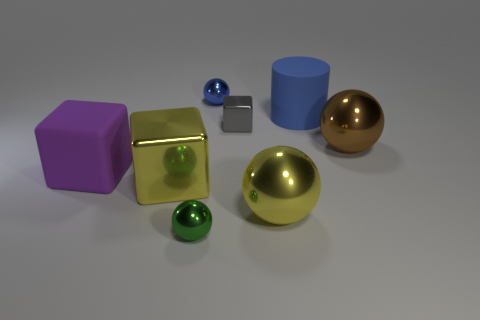Subtract all large yellow metal blocks. How many blocks are left? 2 Add 2 big rubber cubes. How many objects exist? 10 Subtract all green balls. How many balls are left? 3 Add 8 tiny green metallic things. How many tiny green metallic things exist? 9 Subtract 1 gray blocks. How many objects are left? 7 Subtract all cubes. How many objects are left? 5 Subtract all gray balls. Subtract all green cubes. How many balls are left? 4 Subtract all cyan metal cubes. Subtract all small shiny spheres. How many objects are left? 6 Add 4 large blue things. How many large blue things are left? 5 